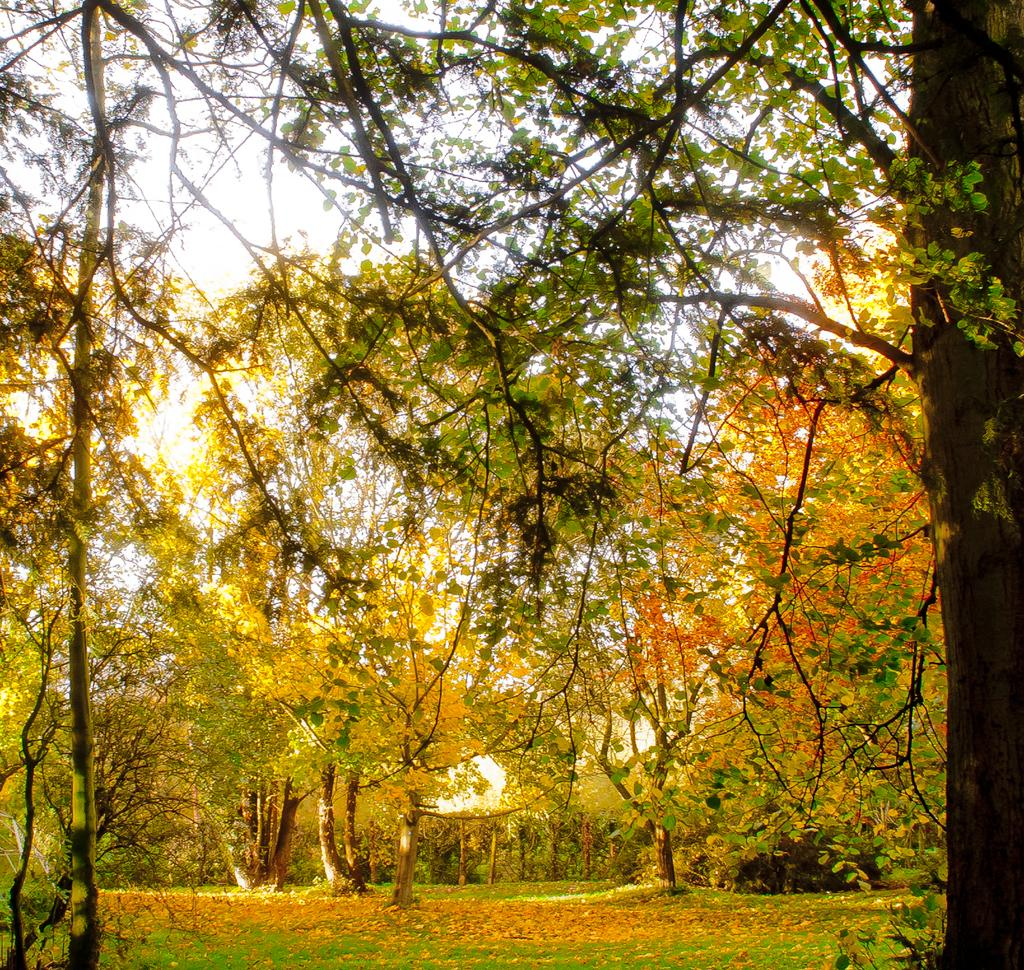What type of vegetation can be seen in the image? There are trees in the image. Who is teaching the parent in the image? There is no teaching or parent present in the image; it only features trees. What type of fiction is being read by the trees in the image? There is no fiction or reading activity present in the image; it only features trees. 